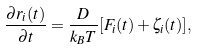Convert formula to latex. <formula><loc_0><loc_0><loc_500><loc_500>\frac { \partial r _ { i } ( t ) } { \partial t } = \frac { D } { k _ { B } T } [ F _ { i } ( t ) + \zeta _ { i } ( t ) ] ,</formula> 